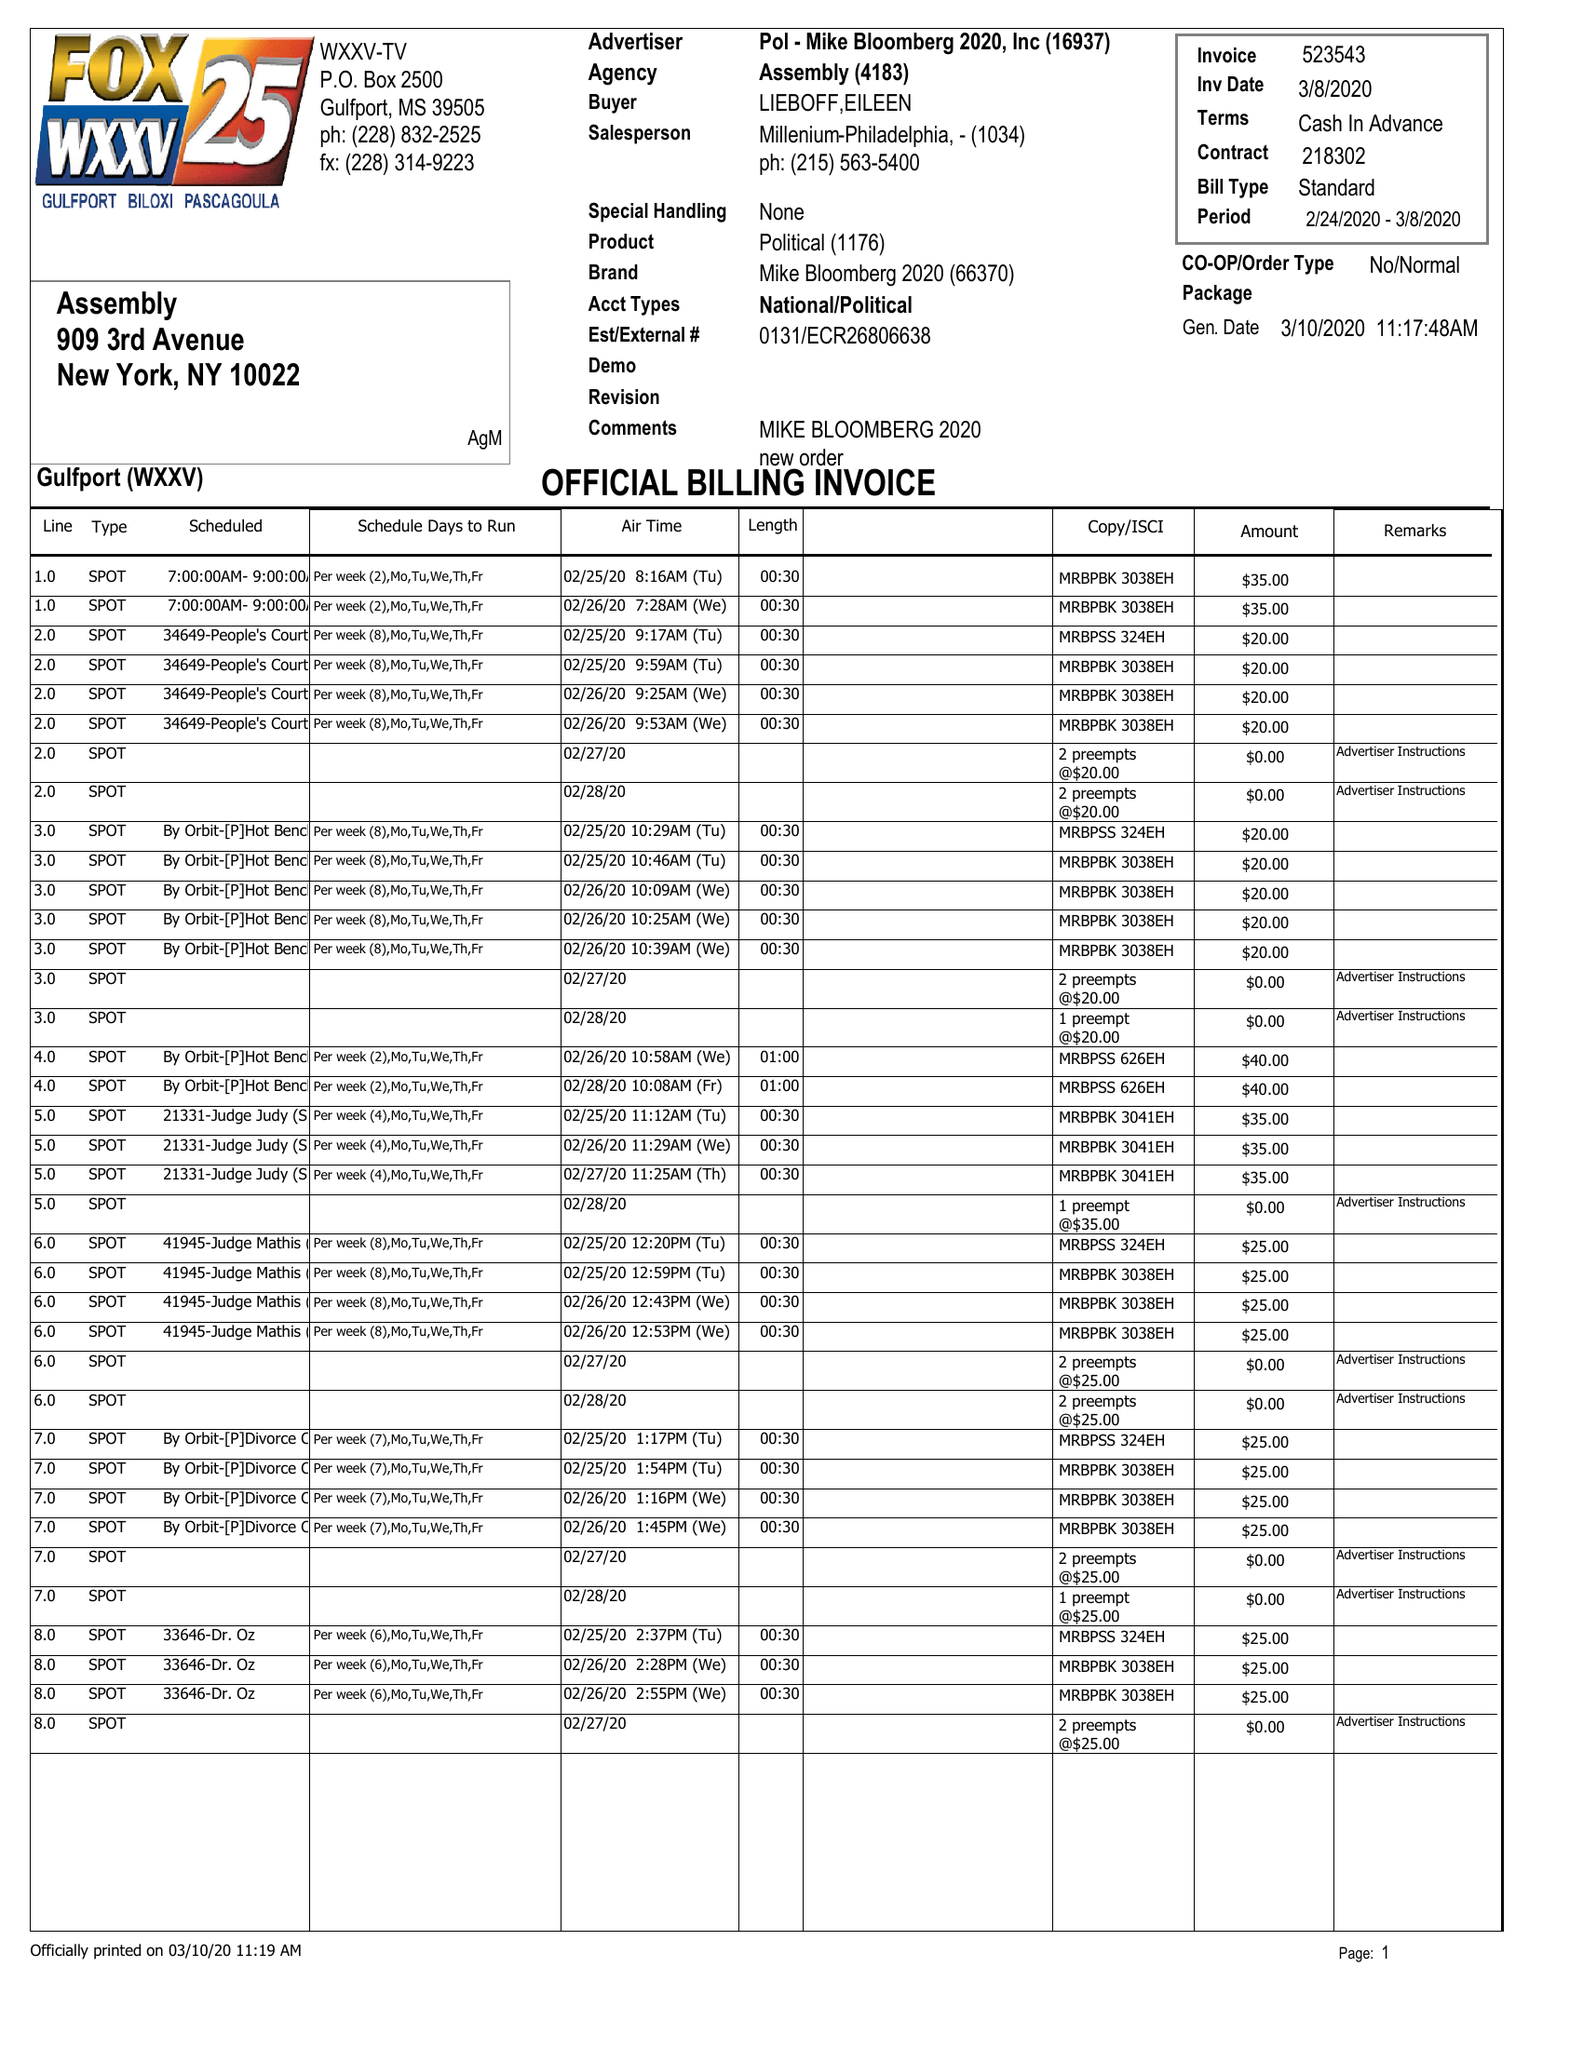What is the value for the flight_to?
Answer the question using a single word or phrase. 03/08/20 